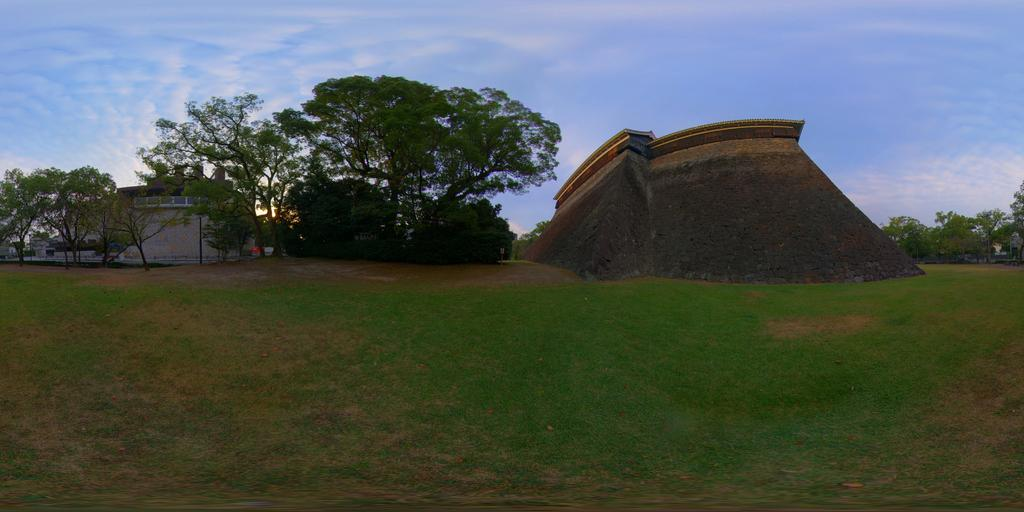What type of location is depicted in the image? There is a construction site in the image. What natural elements can be seen in the image? There are trees and grass visible in the image. What man-made structures are present in the image? There are buildings in the image. What part of the natural environment is visible in the image? The sky is visible in the image. What atmospheric conditions can be observed in the sky? There are clouds in the sky. Can you see a bee flying near the construction site in the image? There is no bee visible in the image. What type of body is present in the image? There are no bodies present in the image; it features a construction site, trees, buildings, grass, and the sky. 